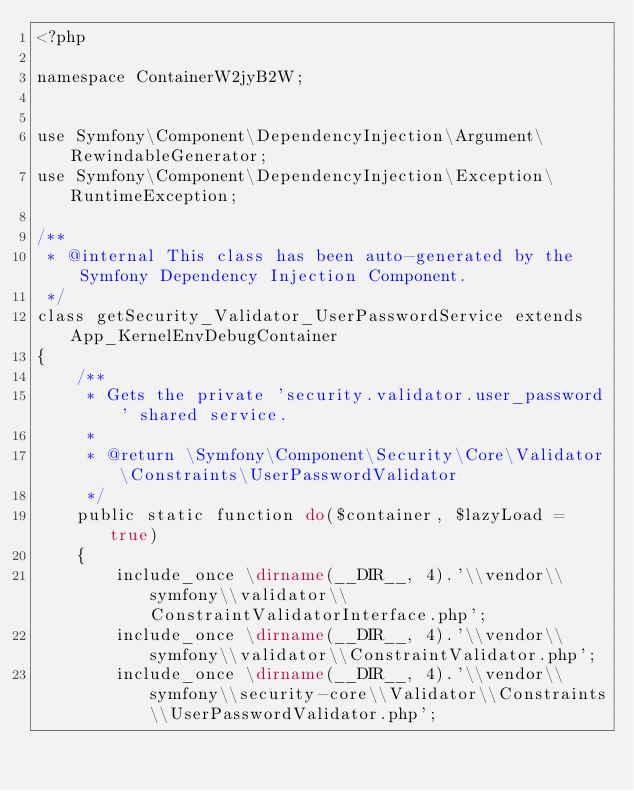<code> <loc_0><loc_0><loc_500><loc_500><_PHP_><?php

namespace ContainerW2jyB2W;


use Symfony\Component\DependencyInjection\Argument\RewindableGenerator;
use Symfony\Component\DependencyInjection\Exception\RuntimeException;

/**
 * @internal This class has been auto-generated by the Symfony Dependency Injection Component.
 */
class getSecurity_Validator_UserPasswordService extends App_KernelEnvDebugContainer
{
    /**
     * Gets the private 'security.validator.user_password' shared service.
     *
     * @return \Symfony\Component\Security\Core\Validator\Constraints\UserPasswordValidator
     */
    public static function do($container, $lazyLoad = true)
    {
        include_once \dirname(__DIR__, 4).'\\vendor\\symfony\\validator\\ConstraintValidatorInterface.php';
        include_once \dirname(__DIR__, 4).'\\vendor\\symfony\\validator\\ConstraintValidator.php';
        include_once \dirname(__DIR__, 4).'\\vendor\\symfony\\security-core\\Validator\\Constraints\\UserPasswordValidator.php';
</code> 